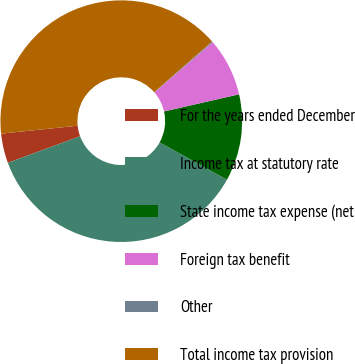<chart> <loc_0><loc_0><loc_500><loc_500><pie_chart><fcel>For the years ended December<fcel>Income tax at statutory rate<fcel>State income tax expense (net<fcel>Foreign tax benefit<fcel>Other<fcel>Total income tax provision<nl><fcel>3.95%<fcel>36.35%<fcel>11.61%<fcel>7.78%<fcel>0.12%<fcel>40.18%<nl></chart> 